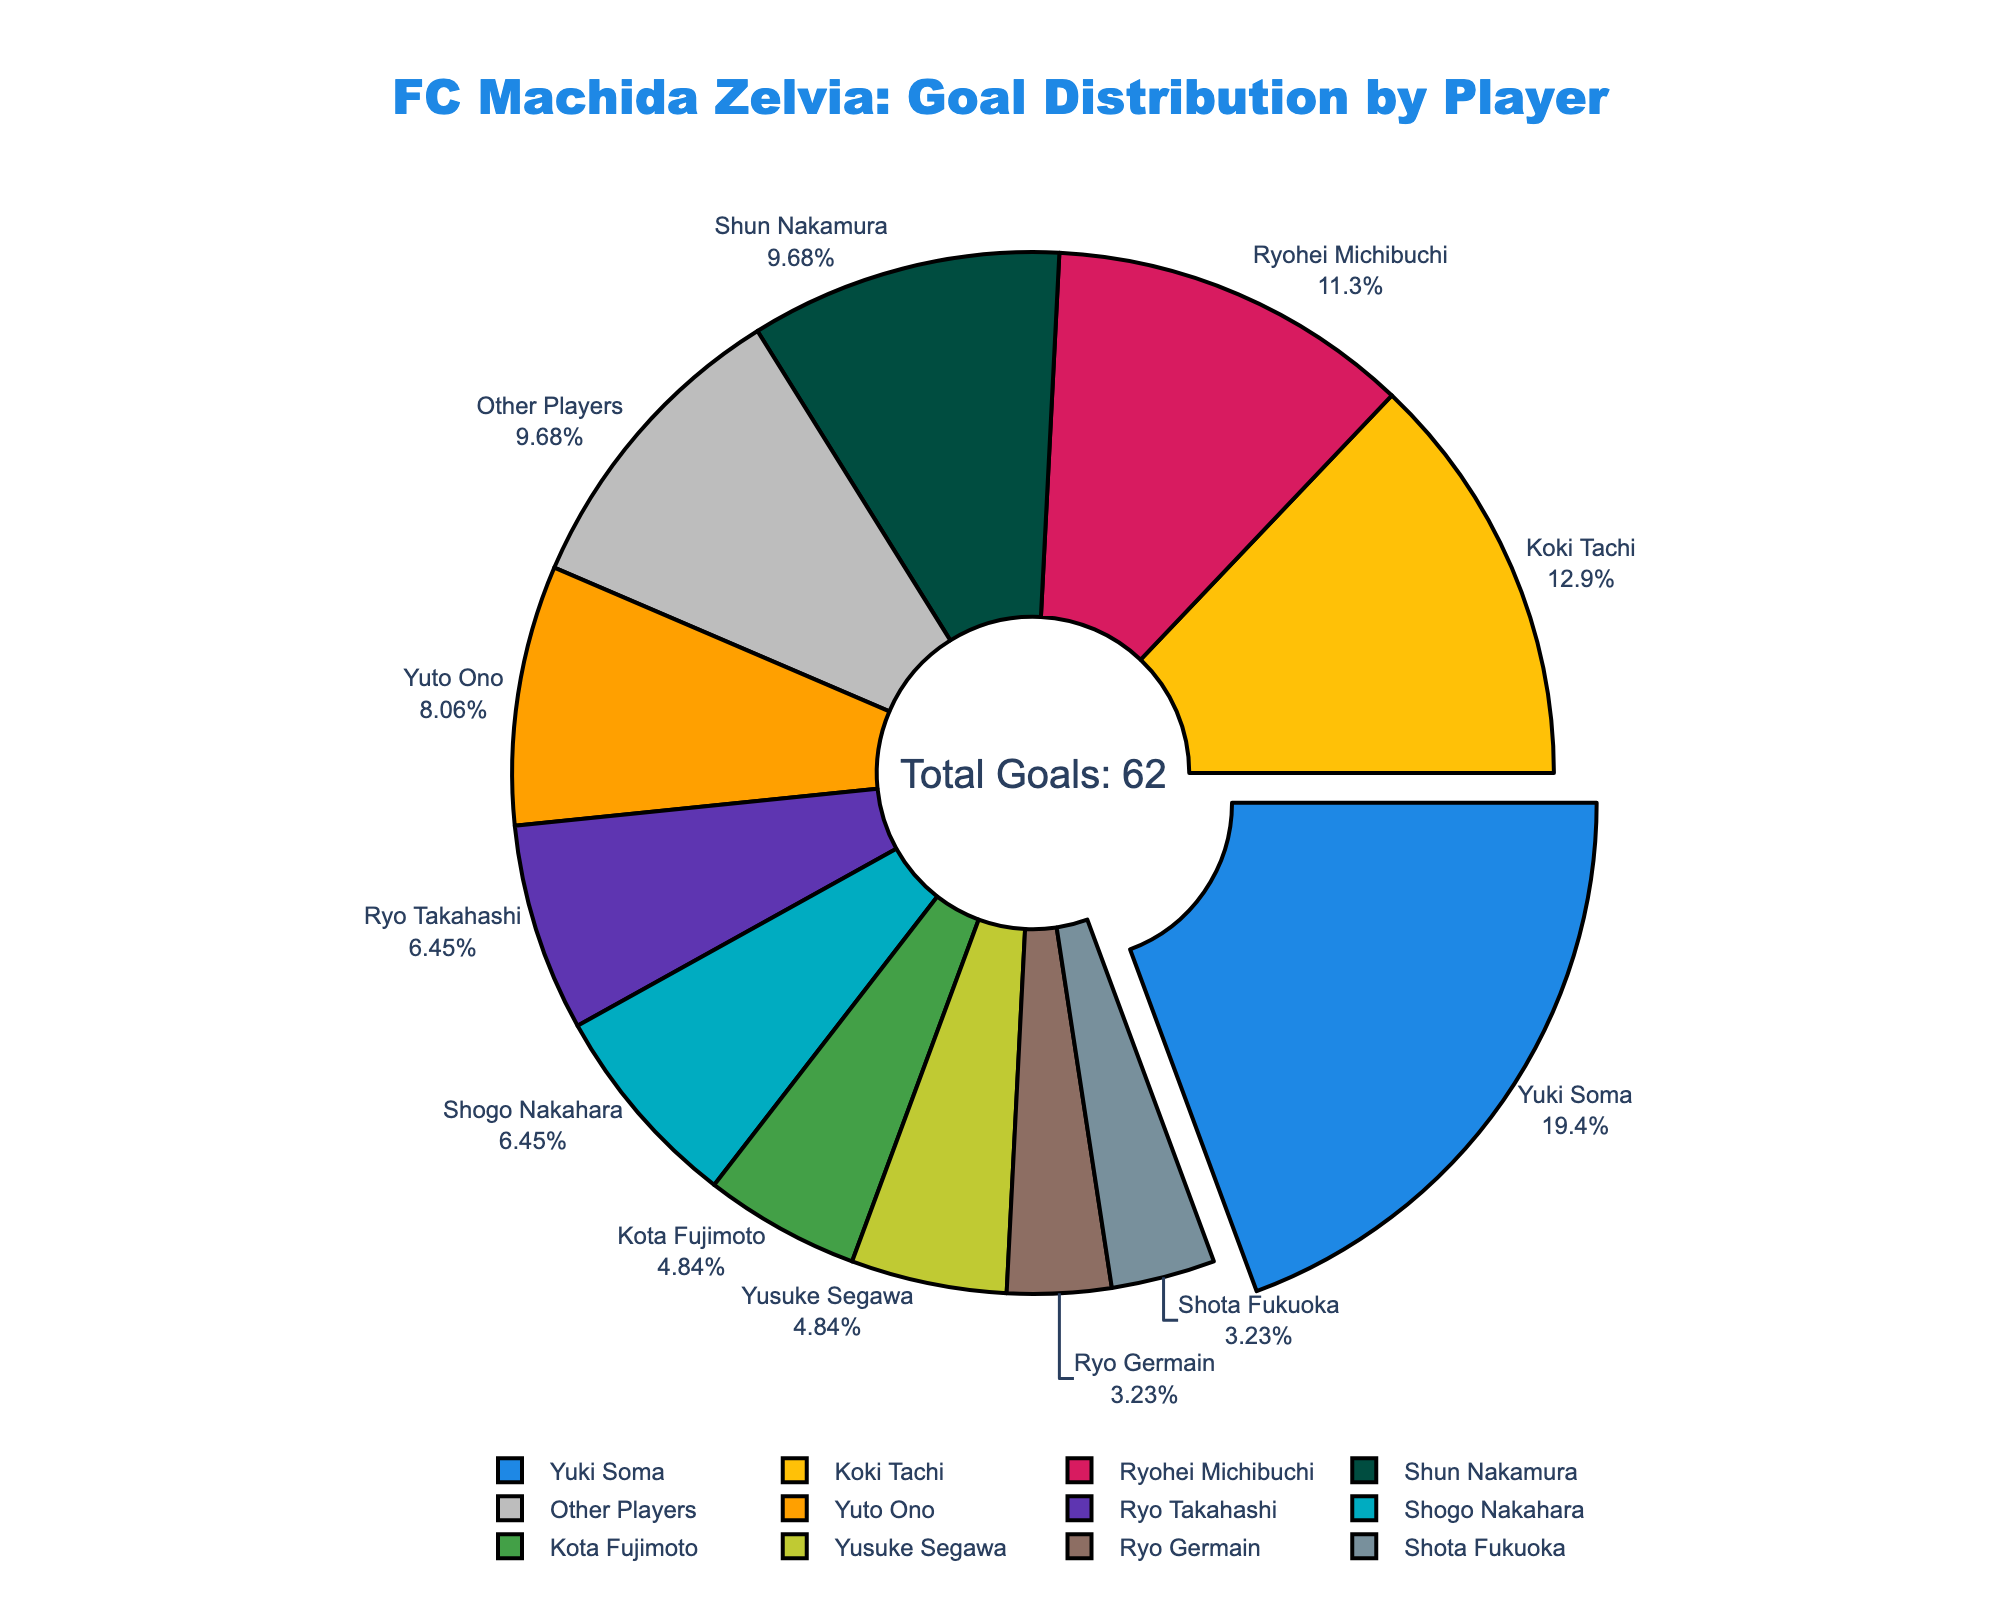Who scored the most goals for FC Machida Zelvia this season? The figure shows Yuki Soma has the largest slice of the pie chart.
Answer: Yuki Soma How many goals did Yuki Soma score compared to Koki Tachi? Yuki Soma's number of goals is 12, while Koki Tachi's is 8. Therefore, Yuki Soma scored 4 more goals than Koki Tachi.
Answer: 4 What percentage of the team's total goals was scored by Ryohei Michibuchi? The pie chart shows each player's contribution in percentages. Ryohei Michibuchi's corresponding slice shows his percentage.
Answer: Approximately 13.73% Which two players scored the same number of goals? The visual information shows both Ryo Takahashi and Shogo Nakahara scored 4 goals each.
Answer: Ryo Takahashi and Shogo Nakahara What is the combined goal total for Shun Nakamura, Yuto Ono, and Ryo Takahashi? Adding their goals, Shun Nakamura scored 6, Yuto Ono 5, and Ryo Takahashi 4. The sum is 6 + 5 + 4 = 15.
Answer: 15 How many goals did players score besides the top scorer, Yuki Soma? Subtract Yuki Soma's goals from the total goals. Yuki Soma scored 12, and the total goals are 62. The calculation is 62 - 12.
Answer: 50 Is the percentage of goals scored by Other Players greater than the percentage scored by Shun Nakamura? Other Players scored 6 goals and Shun Nakamura 6 goals. Each is calculated as a part of total goals (62), so their percentages are equal.
Answer: No Which player scored the least number of goals? Looking at the visual representation, Ryo Germain and Shota Fukuoka scored the least, both with 2 goals.
Answer: Ryo Germain and Shota Fukuoka What is the difference in goals between Yuto Ono and Ryo Germain? Subtract Ryo Germain's goals (2) from Yuto Ono's goals (5). The difference is 5 - 2.
Answer: 3 What is the total number of goals scored by players who scored more than 5 goals? Summing up the goals of Yuki Soma (12), Koki Tachi (8), and Ryohei Michibuchi (7), the total is 12 + 8 + 7.
Answer: 27 